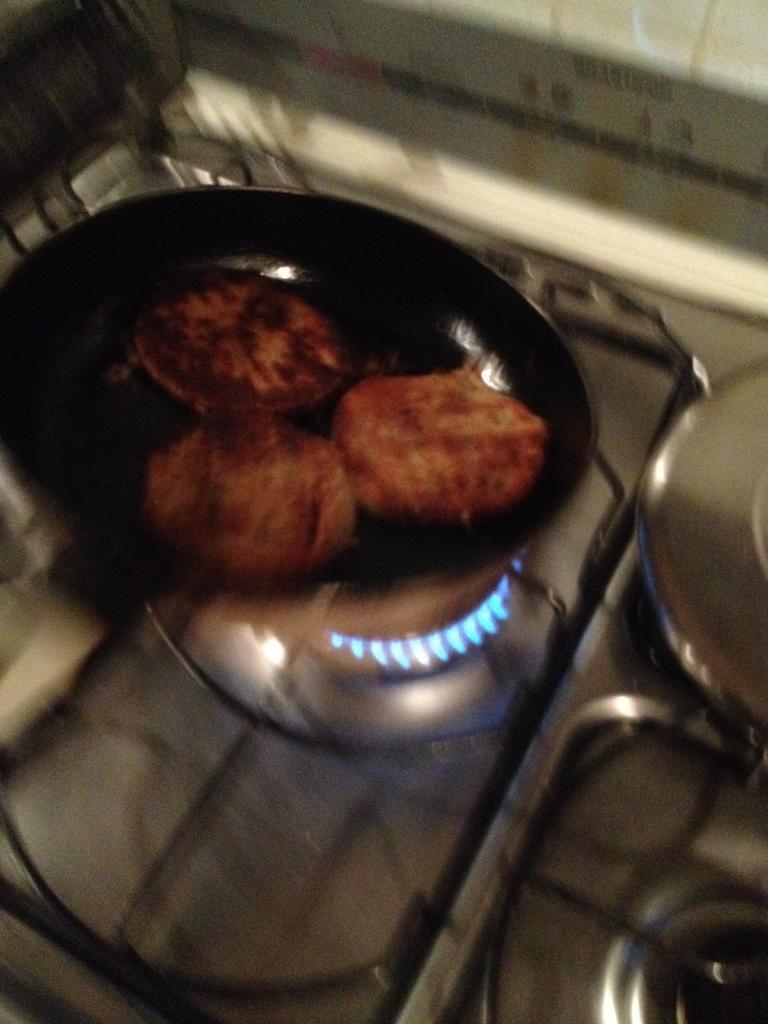Can you describe this image briefly? In this image, there is a pan on the stove. This pane contains some food. 